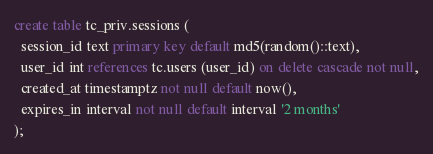<code> <loc_0><loc_0><loc_500><loc_500><_SQL_>create table tc_priv.sessions (
  session_id text primary key default md5(random()::text),
  user_id int references tc.users (user_id) on delete cascade not null,
  created_at timestamptz not null default now(),
  expires_in interval not null default interval '2 months'
);

</code> 